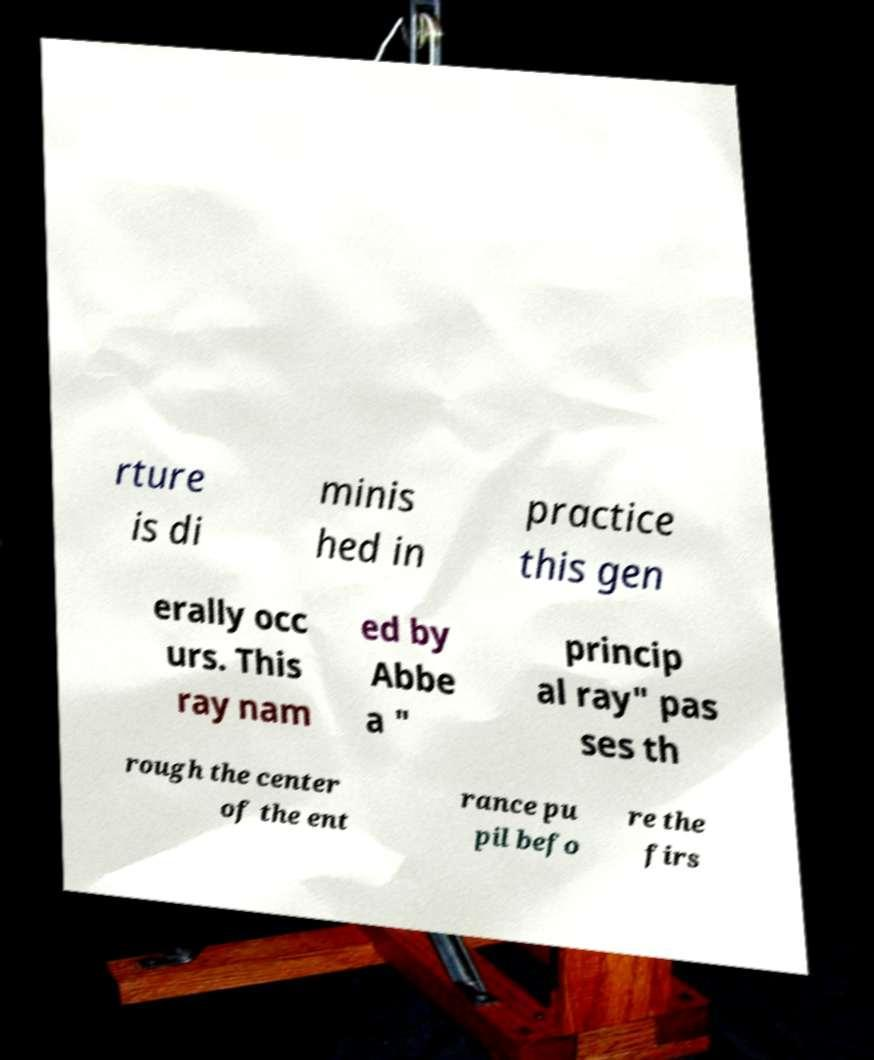Please read and relay the text visible in this image. What does it say? rture is di minis hed in practice this gen erally occ urs. This ray nam ed by Abbe a " princip al ray" pas ses th rough the center of the ent rance pu pil befo re the firs 